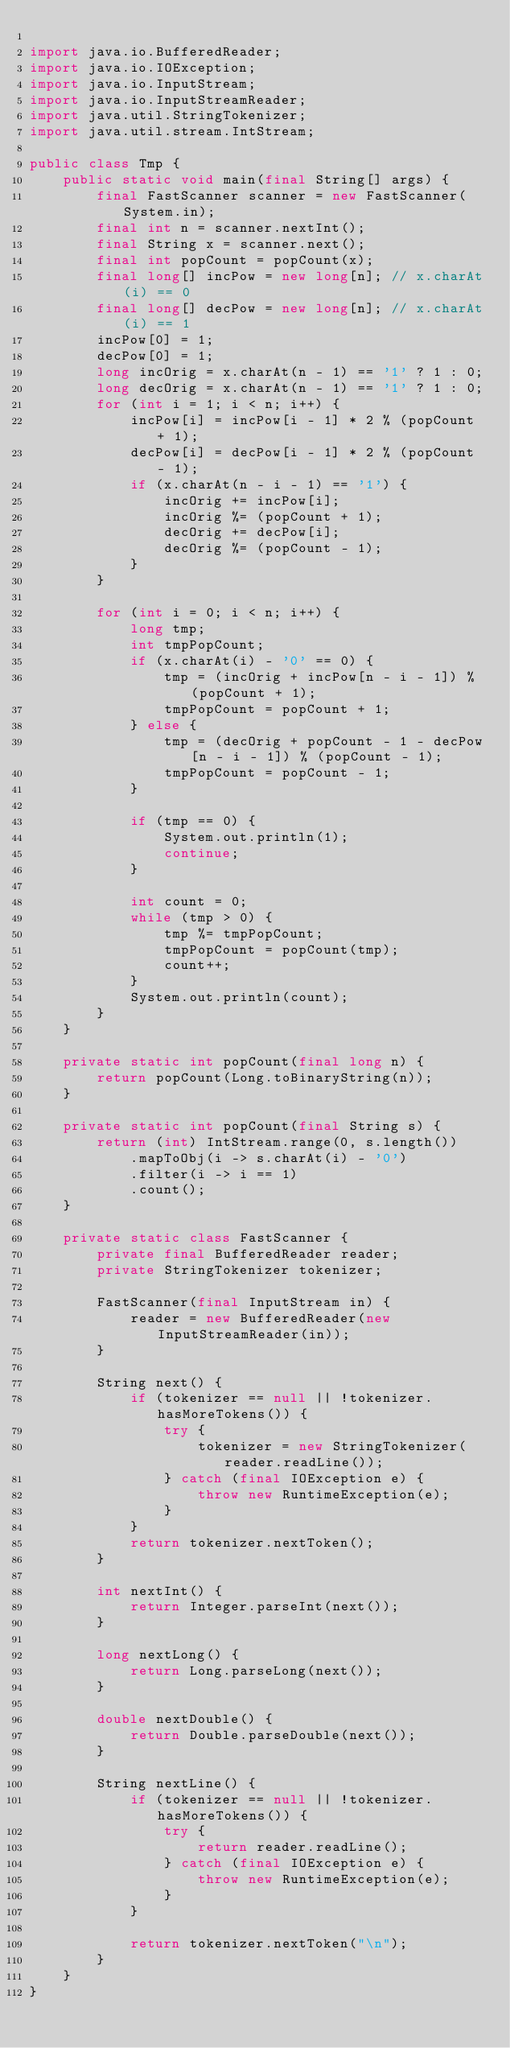Convert code to text. <code><loc_0><loc_0><loc_500><loc_500><_Java_>
import java.io.BufferedReader;
import java.io.IOException;
import java.io.InputStream;
import java.io.InputStreamReader;
import java.util.StringTokenizer;
import java.util.stream.IntStream;

public class Tmp {
    public static void main(final String[] args) {
        final FastScanner scanner = new FastScanner(System.in);
        final int n = scanner.nextInt();
        final String x = scanner.next();
        final int popCount = popCount(x);
        final long[] incPow = new long[n]; // x.charAt(i) == 0
        final long[] decPow = new long[n]; // x.charAt(i) == 1
        incPow[0] = 1;
        decPow[0] = 1;
        long incOrig = x.charAt(n - 1) == '1' ? 1 : 0;
        long decOrig = x.charAt(n - 1) == '1' ? 1 : 0;
        for (int i = 1; i < n; i++) {
            incPow[i] = incPow[i - 1] * 2 % (popCount + 1);
            decPow[i] = decPow[i - 1] * 2 % (popCount - 1);
            if (x.charAt(n - i - 1) == '1') {
                incOrig += incPow[i];
                incOrig %= (popCount + 1);
                decOrig += decPow[i];
                decOrig %= (popCount - 1);
            }
        }

        for (int i = 0; i < n; i++) {
            long tmp;
            int tmpPopCount;
            if (x.charAt(i) - '0' == 0) {
                tmp = (incOrig + incPow[n - i - 1]) % (popCount + 1);
                tmpPopCount = popCount + 1;
            } else {
                tmp = (decOrig + popCount - 1 - decPow[n - i - 1]) % (popCount - 1);
                tmpPopCount = popCount - 1;
            }

            if (tmp == 0) {
                System.out.println(1);
                continue;
            }

            int count = 0;
            while (tmp > 0) {
                tmp %= tmpPopCount;
                tmpPopCount = popCount(tmp);
                count++;
            }
            System.out.println(count);
        }
    }

    private static int popCount(final long n) {
        return popCount(Long.toBinaryString(n));
    }

    private static int popCount(final String s) {
        return (int) IntStream.range(0, s.length())
            .mapToObj(i -> s.charAt(i) - '0')
            .filter(i -> i == 1)
            .count();
    }

    private static class FastScanner {
        private final BufferedReader reader;
        private StringTokenizer tokenizer;

        FastScanner(final InputStream in) {
            reader = new BufferedReader(new InputStreamReader(in));
        }

        String next() {
            if (tokenizer == null || !tokenizer.hasMoreTokens()) {
                try {
                    tokenizer = new StringTokenizer(reader.readLine());
                } catch (final IOException e) {
                    throw new RuntimeException(e);
                }
            }
            return tokenizer.nextToken();
        }

        int nextInt() {
            return Integer.parseInt(next());
        }

        long nextLong() {
            return Long.parseLong(next());
        }

        double nextDouble() {
            return Double.parseDouble(next());
        }

        String nextLine() {
            if (tokenizer == null || !tokenizer.hasMoreTokens()) {
                try {
                    return reader.readLine();
                } catch (final IOException e) {
                    throw new RuntimeException(e);
                }
            }

            return tokenizer.nextToken("\n");
        }
    }
}
</code> 